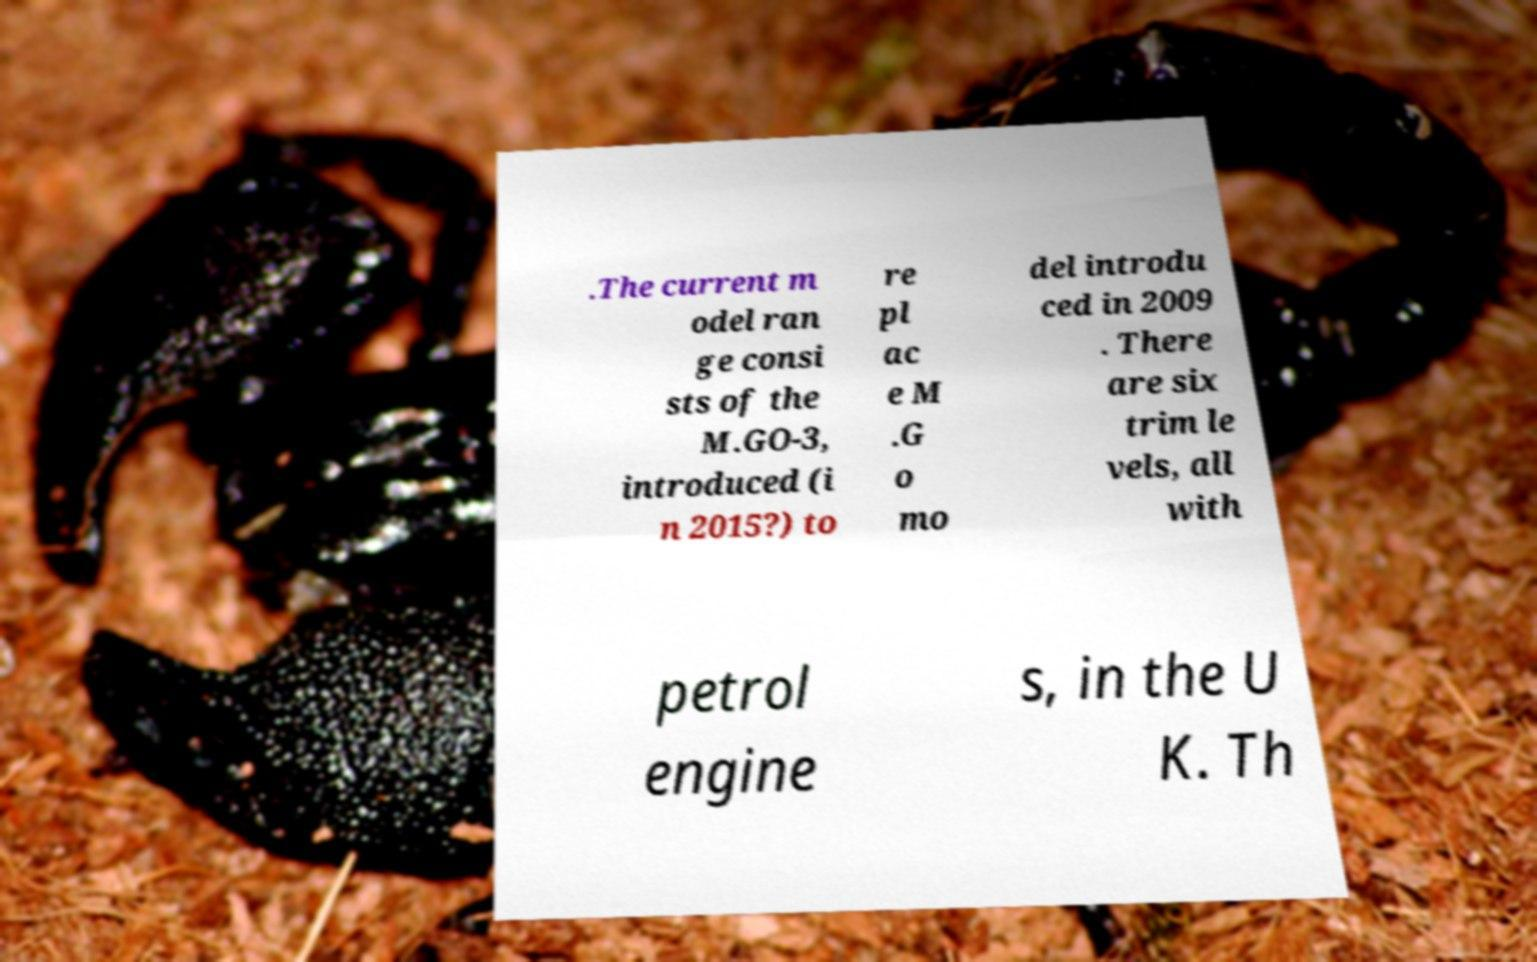Could you assist in decoding the text presented in this image and type it out clearly? .The current m odel ran ge consi sts of the M.GO-3, introduced (i n 2015?) to re pl ac e M .G o mo del introdu ced in 2009 . There are six trim le vels, all with petrol engine s, in the U K. Th 